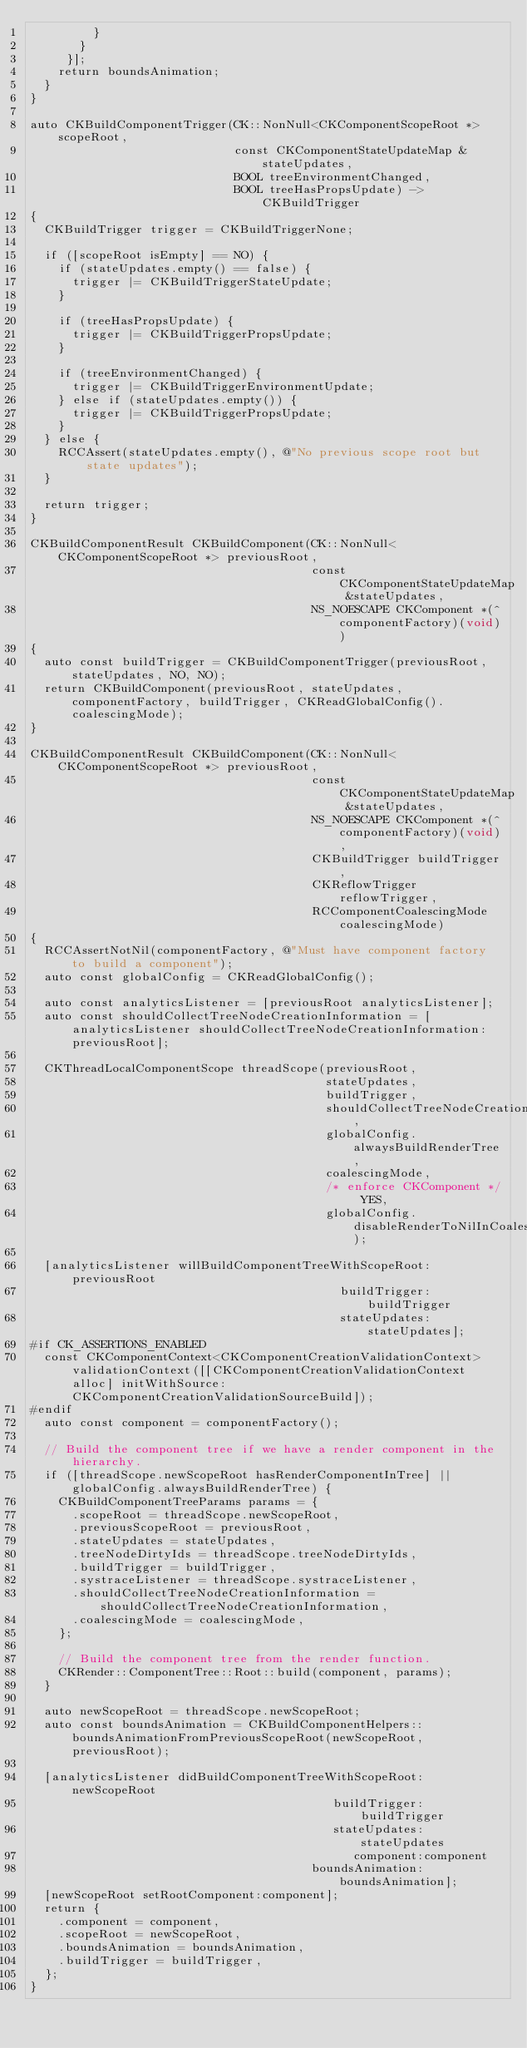<code> <loc_0><loc_0><loc_500><loc_500><_ObjectiveC_>         }
       }
     }];
    return boundsAnimation;
  }
}

auto CKBuildComponentTrigger(CK::NonNull<CKComponentScopeRoot *> scopeRoot,
                             const CKComponentStateUpdateMap &stateUpdates,
                             BOOL treeEnvironmentChanged,
                             BOOL treeHasPropsUpdate) -> CKBuildTrigger
{
  CKBuildTrigger trigger = CKBuildTriggerNone;

  if ([scopeRoot isEmpty] == NO) {
    if (stateUpdates.empty() == false) {
      trigger |= CKBuildTriggerStateUpdate;
    }

    if (treeHasPropsUpdate) {
      trigger |= CKBuildTriggerPropsUpdate;
    }

    if (treeEnvironmentChanged) {
      trigger |= CKBuildTriggerEnvironmentUpdate;
    } else if (stateUpdates.empty()) {
      trigger |= CKBuildTriggerPropsUpdate;
    }
  } else {
    RCCAssert(stateUpdates.empty(), @"No previous scope root but state updates");
  }

  return trigger;
}

CKBuildComponentResult CKBuildComponent(CK::NonNull<CKComponentScopeRoot *> previousRoot,
                                        const CKComponentStateUpdateMap &stateUpdates,
                                        NS_NOESCAPE CKComponent *(^componentFactory)(void))
{
  auto const buildTrigger = CKBuildComponentTrigger(previousRoot, stateUpdates, NO, NO);
  return CKBuildComponent(previousRoot, stateUpdates, componentFactory, buildTrigger, CKReadGlobalConfig().coalescingMode);
}

CKBuildComponentResult CKBuildComponent(CK::NonNull<CKComponentScopeRoot *> previousRoot,
                                        const CKComponentStateUpdateMap &stateUpdates,
                                        NS_NOESCAPE CKComponent *(^componentFactory)(void),
                                        CKBuildTrigger buildTrigger,
                                        CKReflowTrigger reflowTrigger,
                                        RCComponentCoalescingMode coalescingMode)
{
  RCCAssertNotNil(componentFactory, @"Must have component factory to build a component");
  auto const globalConfig = CKReadGlobalConfig();

  auto const analyticsListener = [previousRoot analyticsListener];
  auto const shouldCollectTreeNodeCreationInformation = [analyticsListener shouldCollectTreeNodeCreationInformation:previousRoot];

  CKThreadLocalComponentScope threadScope(previousRoot,
                                          stateUpdates,
                                          buildTrigger,
                                          shouldCollectTreeNodeCreationInformation,
                                          globalConfig.alwaysBuildRenderTree,
                                          coalescingMode,
                                          /* enforce CKComponent */ YES,
                                          globalConfig.disableRenderToNilInCoalescedCompositeComponents);

  [analyticsListener willBuildComponentTreeWithScopeRoot:previousRoot
                                            buildTrigger:buildTrigger
                                            stateUpdates:stateUpdates];
#if CK_ASSERTIONS_ENABLED
  const CKComponentContext<CKComponentCreationValidationContext> validationContext([[CKComponentCreationValidationContext alloc] initWithSource:CKComponentCreationValidationSourceBuild]);
#endif
  auto const component = componentFactory();

  // Build the component tree if we have a render component in the hierarchy.
  if ([threadScope.newScopeRoot hasRenderComponentInTree] || globalConfig.alwaysBuildRenderTree) {
    CKBuildComponentTreeParams params = {
      .scopeRoot = threadScope.newScopeRoot,
      .previousScopeRoot = previousRoot,
      .stateUpdates = stateUpdates,
      .treeNodeDirtyIds = threadScope.treeNodeDirtyIds,
      .buildTrigger = buildTrigger,
      .systraceListener = threadScope.systraceListener,
      .shouldCollectTreeNodeCreationInformation = shouldCollectTreeNodeCreationInformation,
      .coalescingMode = coalescingMode,
    };

    // Build the component tree from the render function.
    CKRender::ComponentTree::Root::build(component, params);
  }

  auto newScopeRoot = threadScope.newScopeRoot;
  auto const boundsAnimation = CKBuildComponentHelpers::boundsAnimationFromPreviousScopeRoot(newScopeRoot, previousRoot);

  [analyticsListener didBuildComponentTreeWithScopeRoot:newScopeRoot
                                           buildTrigger:buildTrigger
                                           stateUpdates:stateUpdates
                                              component:component
                                        boundsAnimation:boundsAnimation];
  [newScopeRoot setRootComponent:component];
  return {
    .component = component,
    .scopeRoot = newScopeRoot,
    .boundsAnimation = boundsAnimation,
    .buildTrigger = buildTrigger,
  };
}
</code> 